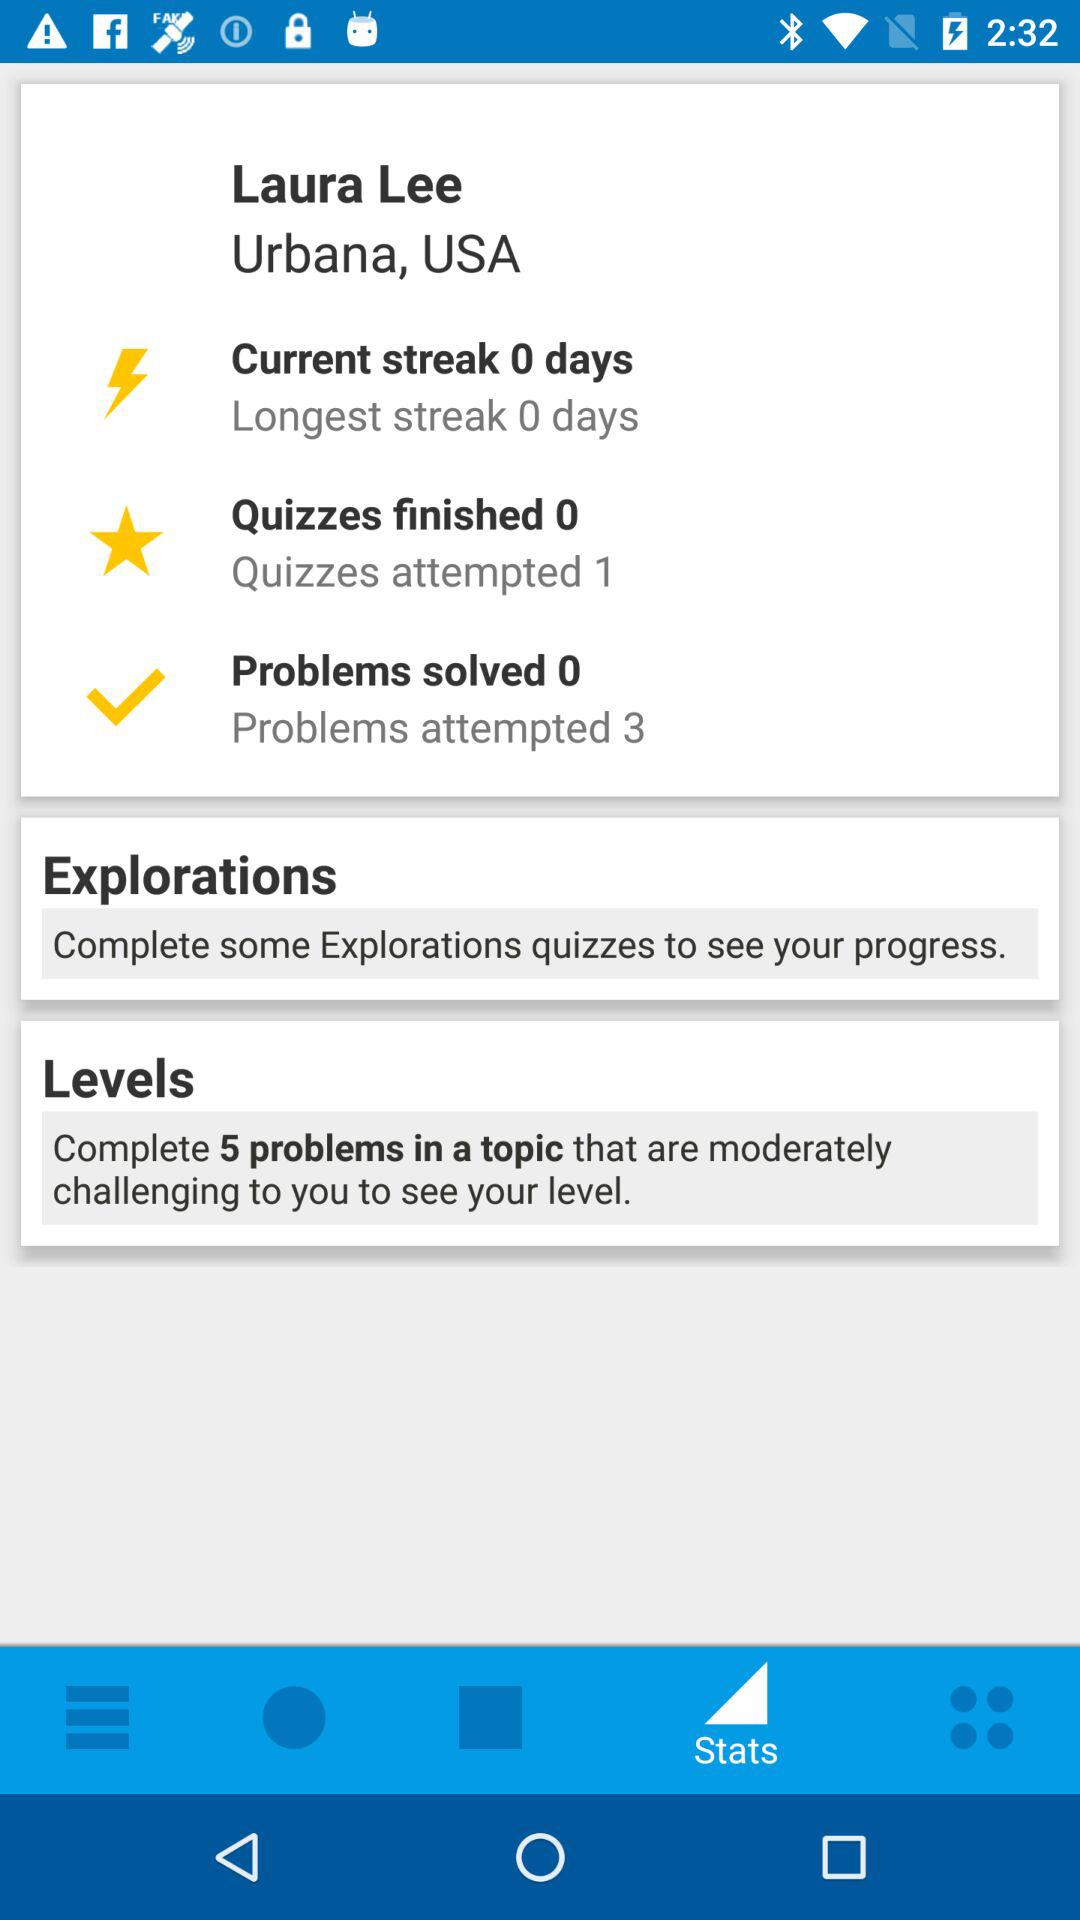What is the given location? The given location is Urbana, USA. 